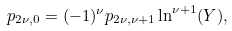<formula> <loc_0><loc_0><loc_500><loc_500>p _ { 2 \nu , 0 } = ( - 1 ) ^ { \nu } p _ { 2 \nu , \nu + 1 } \ln ^ { \nu + 1 } ( Y ) ,</formula> 